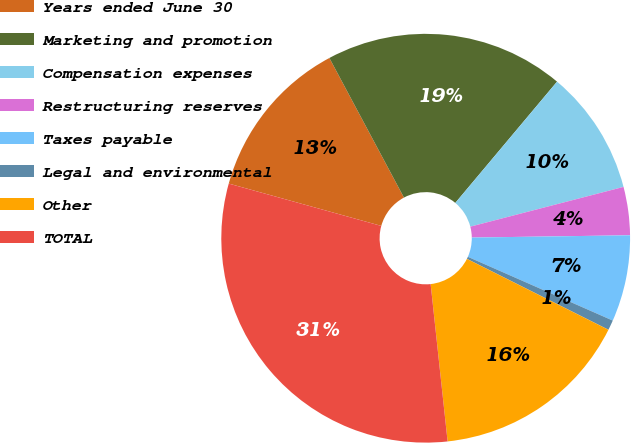Convert chart. <chart><loc_0><loc_0><loc_500><loc_500><pie_chart><fcel>Years ended June 30<fcel>Marketing and promotion<fcel>Compensation expenses<fcel>Restructuring reserves<fcel>Taxes payable<fcel>Legal and environmental<fcel>Other<fcel>TOTAL<nl><fcel>12.88%<fcel>18.92%<fcel>9.85%<fcel>3.81%<fcel>6.83%<fcel>0.79%<fcel>15.9%<fcel>31.02%<nl></chart> 